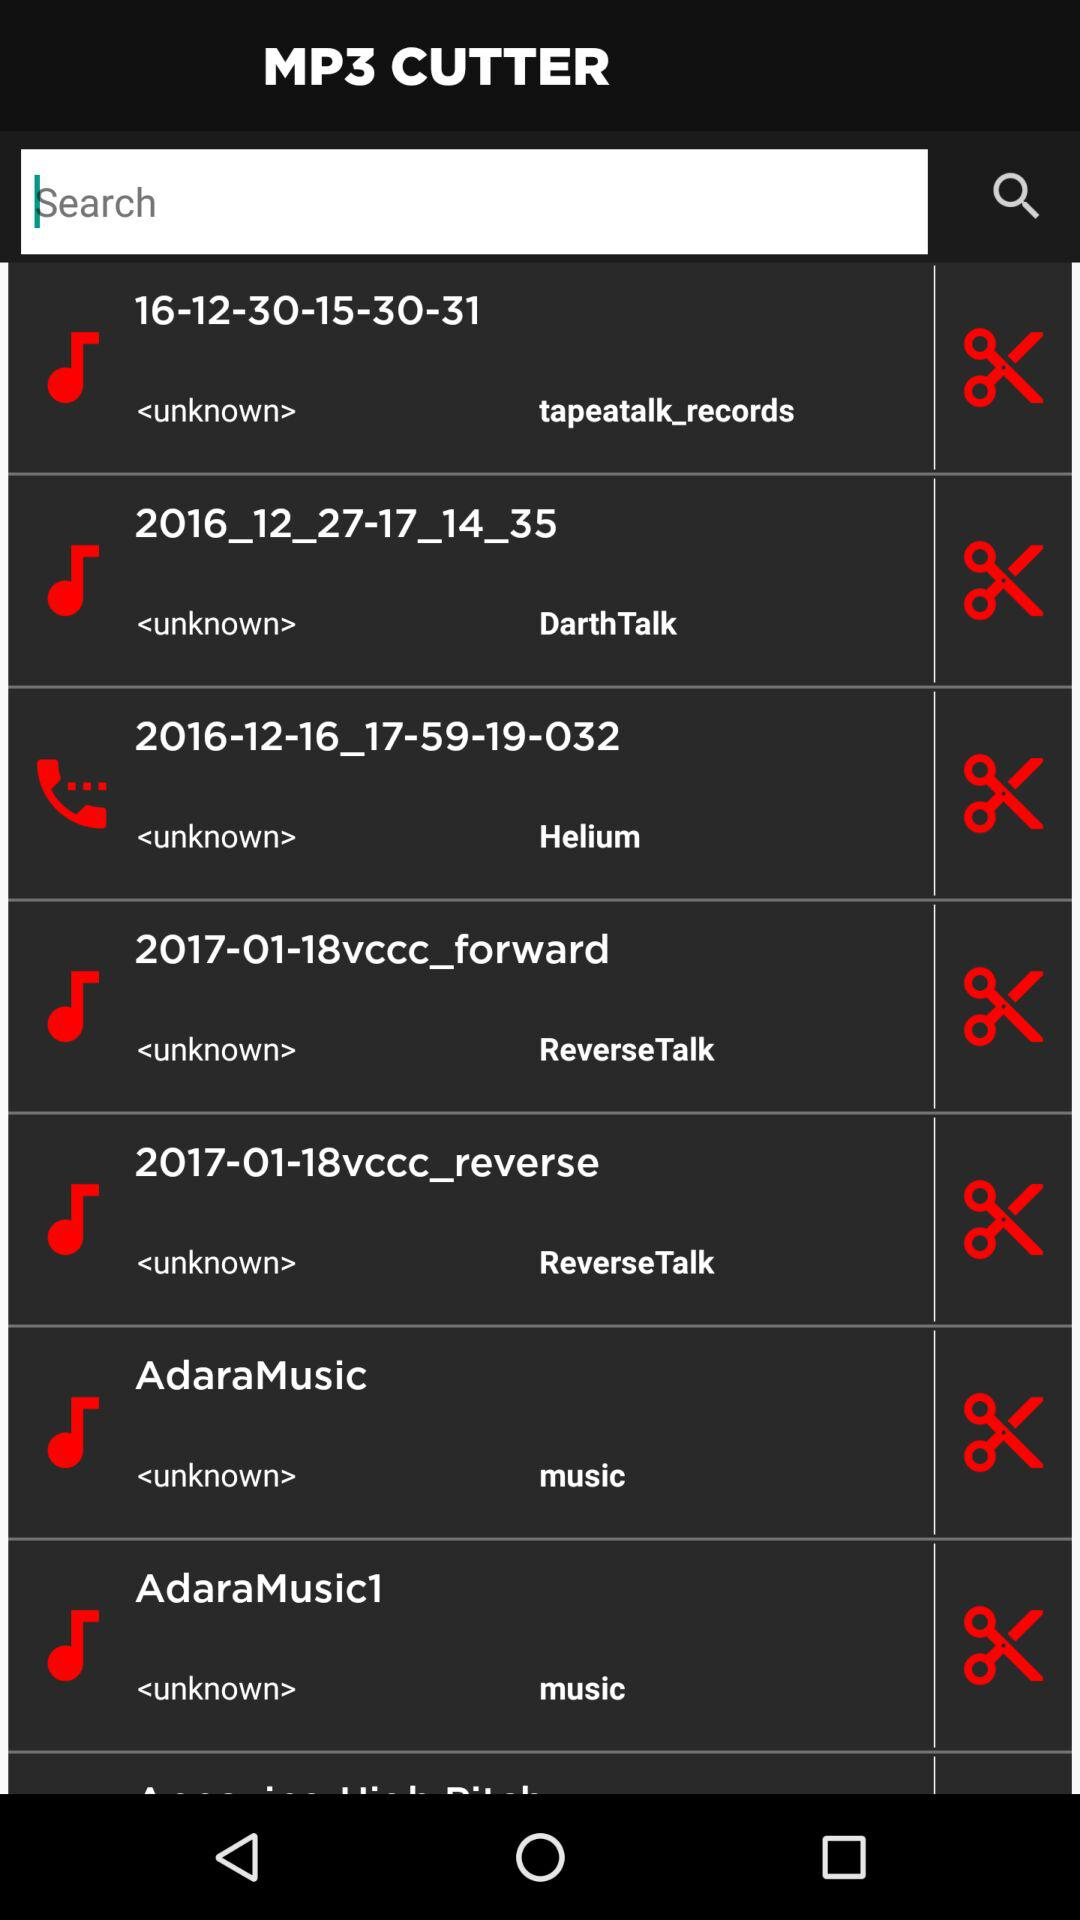What is the date of Helium?
When the provided information is insufficient, respond with <no answer>. <no answer> 